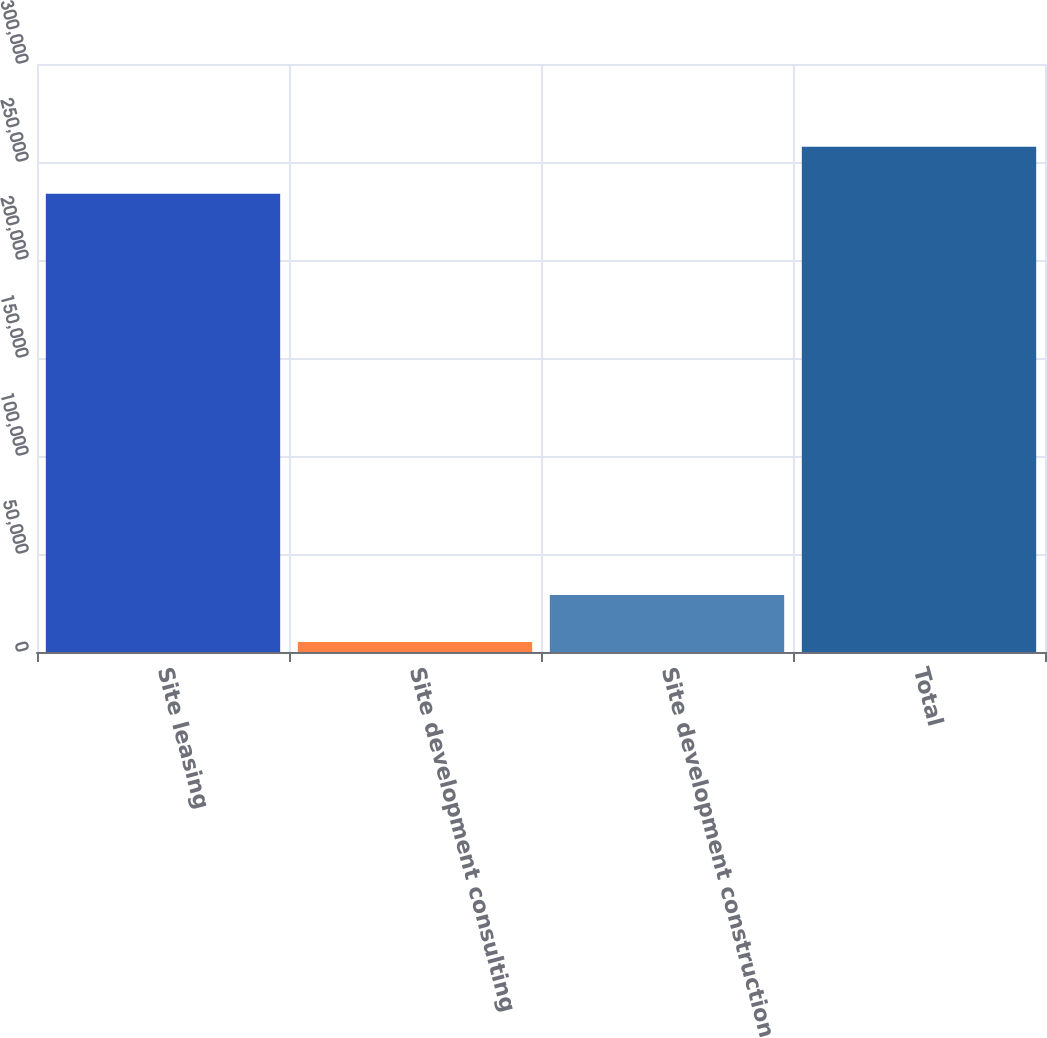Convert chart to OTSL. <chart><loc_0><loc_0><loc_500><loc_500><bar_chart><fcel>Site leasing<fcel>Site development consulting<fcel>Site development construction<fcel>Total<nl><fcel>233812<fcel>5054<fcel>29033.4<fcel>257791<nl></chart> 